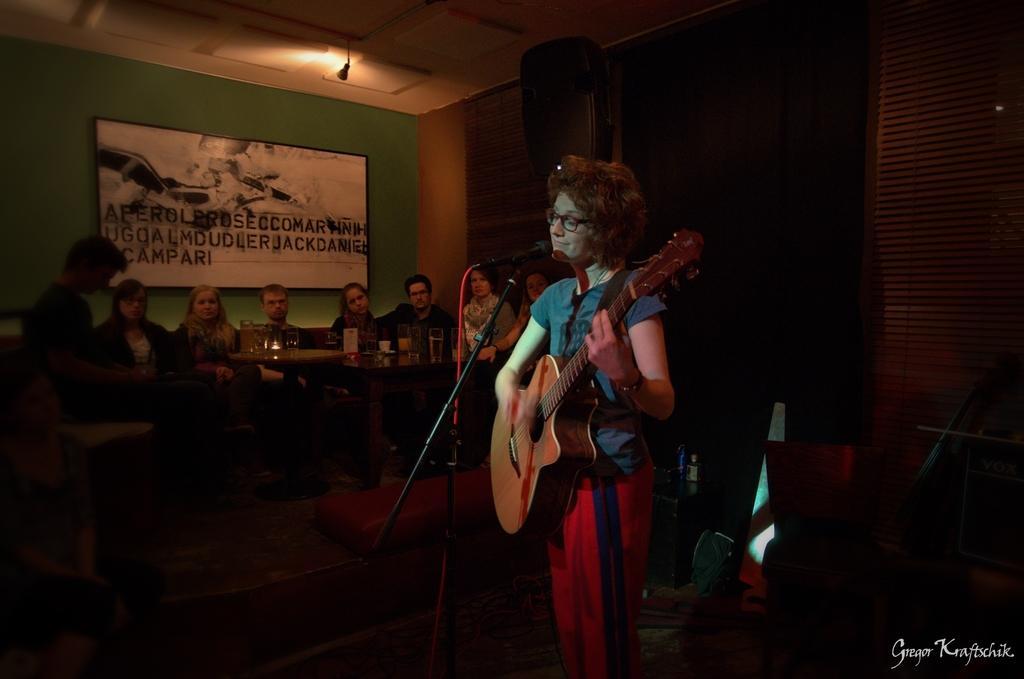Describe this image in one or two sentences. In this picture we can see a woman who is standing in front of mike. She has spectacles and she is playing guitar. On the background we can see some persons are sitting on the chairs. This is table. On the table there are glasses. This is wall and there is a frame. Here we can see a light. 